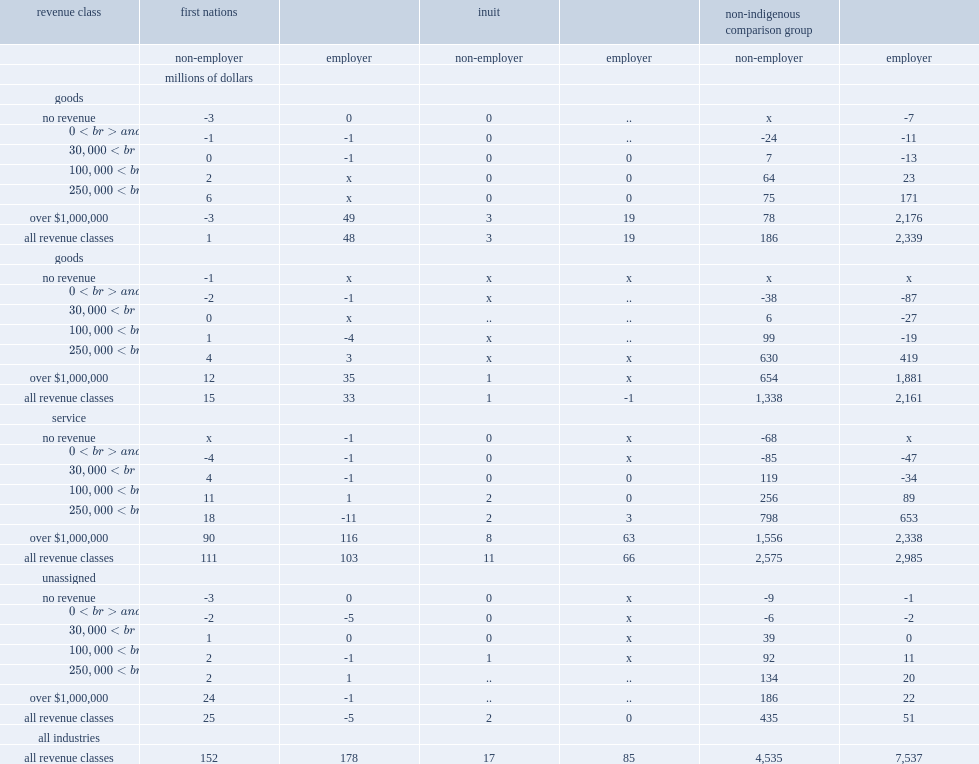Which revenue class did the largest shares of profits make by businesses for nearly all csd type, employer status and industry combinations? Over $1,000,000. Which revenue class did the largest shares of profits make by businesses for nearly all csd type, employer status and industry combinations? Over $1,000,000. 